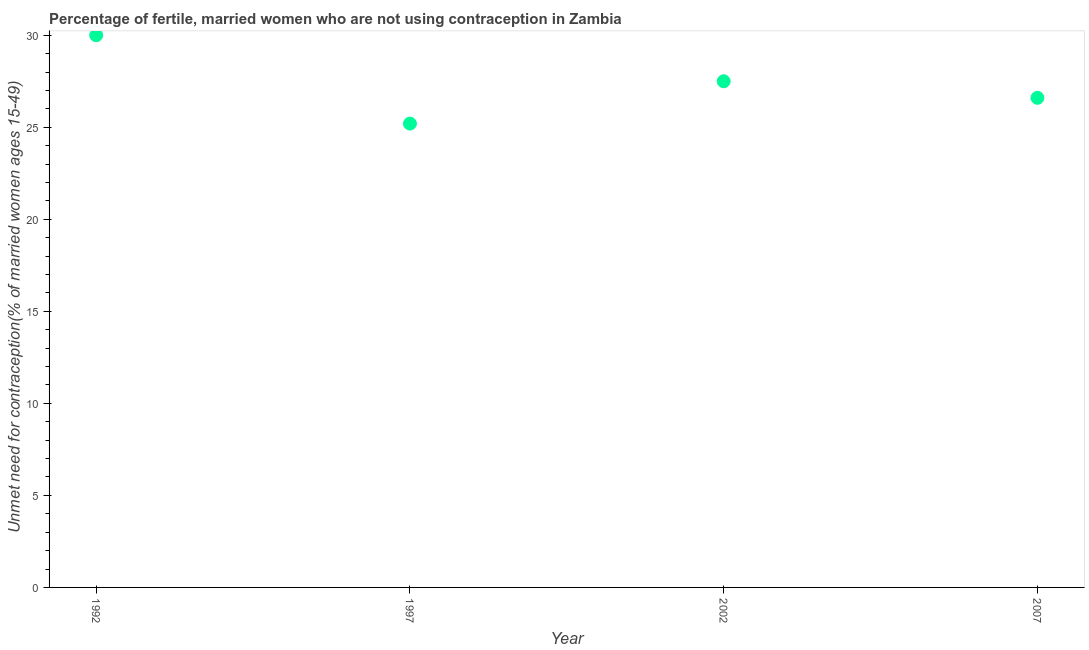What is the number of married women who are not using contraception in 1997?
Your answer should be very brief. 25.2. Across all years, what is the minimum number of married women who are not using contraception?
Your answer should be very brief. 25.2. What is the sum of the number of married women who are not using contraception?
Provide a succinct answer. 109.3. What is the difference between the number of married women who are not using contraception in 2002 and 2007?
Your answer should be compact. 0.9. What is the average number of married women who are not using contraception per year?
Provide a short and direct response. 27.33. What is the median number of married women who are not using contraception?
Provide a short and direct response. 27.05. What is the ratio of the number of married women who are not using contraception in 1997 to that in 2007?
Offer a very short reply. 0.95. Is the number of married women who are not using contraception in 1992 less than that in 2007?
Your response must be concise. No. What is the difference between the highest and the lowest number of married women who are not using contraception?
Your answer should be very brief. 4.8. Does the number of married women who are not using contraception monotonically increase over the years?
Keep it short and to the point. No. How many dotlines are there?
Provide a short and direct response. 1. How many years are there in the graph?
Make the answer very short. 4. What is the difference between two consecutive major ticks on the Y-axis?
Your answer should be very brief. 5. Does the graph contain any zero values?
Ensure brevity in your answer.  No. What is the title of the graph?
Provide a short and direct response. Percentage of fertile, married women who are not using contraception in Zambia. What is the label or title of the X-axis?
Your response must be concise. Year. What is the label or title of the Y-axis?
Offer a terse response.  Unmet need for contraception(% of married women ages 15-49). What is the  Unmet need for contraception(% of married women ages 15-49) in 1997?
Provide a short and direct response. 25.2. What is the  Unmet need for contraception(% of married women ages 15-49) in 2002?
Give a very brief answer. 27.5. What is the  Unmet need for contraception(% of married women ages 15-49) in 2007?
Offer a very short reply. 26.6. What is the difference between the  Unmet need for contraception(% of married women ages 15-49) in 1992 and 1997?
Your answer should be compact. 4.8. What is the difference between the  Unmet need for contraception(% of married women ages 15-49) in 1997 and 2002?
Offer a very short reply. -2.3. What is the difference between the  Unmet need for contraception(% of married women ages 15-49) in 2002 and 2007?
Your answer should be very brief. 0.9. What is the ratio of the  Unmet need for contraception(% of married women ages 15-49) in 1992 to that in 1997?
Provide a short and direct response. 1.19. What is the ratio of the  Unmet need for contraception(% of married women ages 15-49) in 1992 to that in 2002?
Give a very brief answer. 1.09. What is the ratio of the  Unmet need for contraception(% of married women ages 15-49) in 1992 to that in 2007?
Offer a very short reply. 1.13. What is the ratio of the  Unmet need for contraception(% of married women ages 15-49) in 1997 to that in 2002?
Provide a short and direct response. 0.92. What is the ratio of the  Unmet need for contraception(% of married women ages 15-49) in 1997 to that in 2007?
Your response must be concise. 0.95. What is the ratio of the  Unmet need for contraception(% of married women ages 15-49) in 2002 to that in 2007?
Offer a terse response. 1.03. 